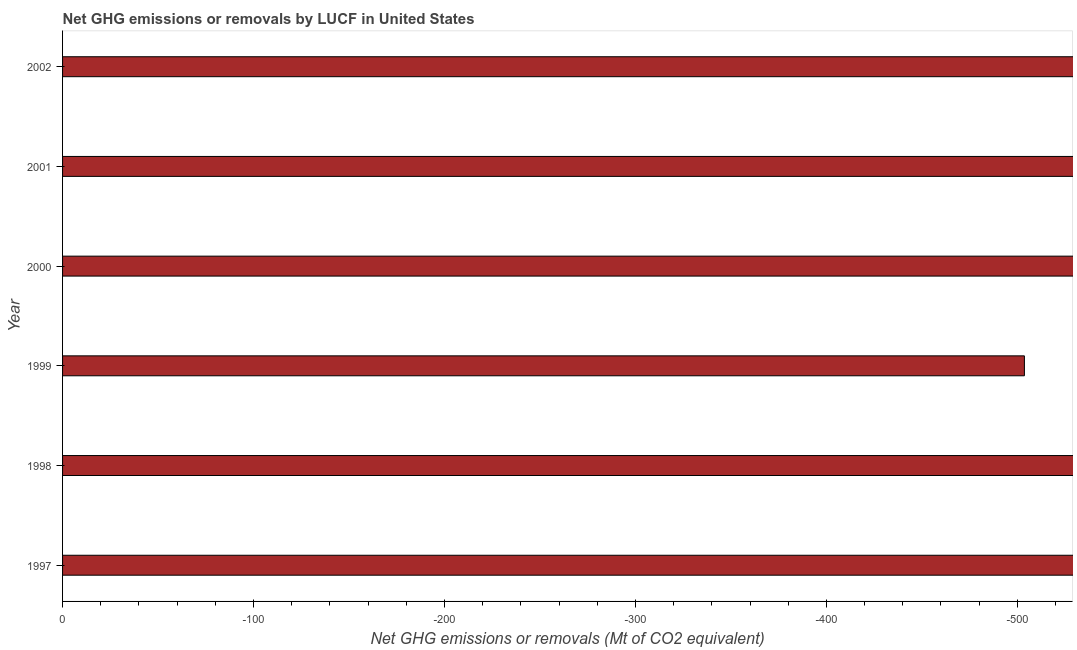Does the graph contain any zero values?
Your response must be concise. Yes. Does the graph contain grids?
Provide a short and direct response. No. What is the title of the graph?
Make the answer very short. Net GHG emissions or removals by LUCF in United States. What is the label or title of the X-axis?
Your answer should be very brief. Net GHG emissions or removals (Mt of CO2 equivalent). Across all years, what is the minimum ghg net emissions or removals?
Your answer should be very brief. 0. What is the average ghg net emissions or removals per year?
Offer a terse response. 0. What is the median ghg net emissions or removals?
Offer a terse response. 0. In how many years, is the ghg net emissions or removals greater than the average ghg net emissions or removals taken over all years?
Your answer should be very brief. 0. How many bars are there?
Provide a succinct answer. 0. How many years are there in the graph?
Offer a terse response. 6. What is the Net GHG emissions or removals (Mt of CO2 equivalent) of 1997?
Ensure brevity in your answer.  0. What is the Net GHG emissions or removals (Mt of CO2 equivalent) of 2000?
Your answer should be compact. 0. What is the Net GHG emissions or removals (Mt of CO2 equivalent) in 2002?
Ensure brevity in your answer.  0. 